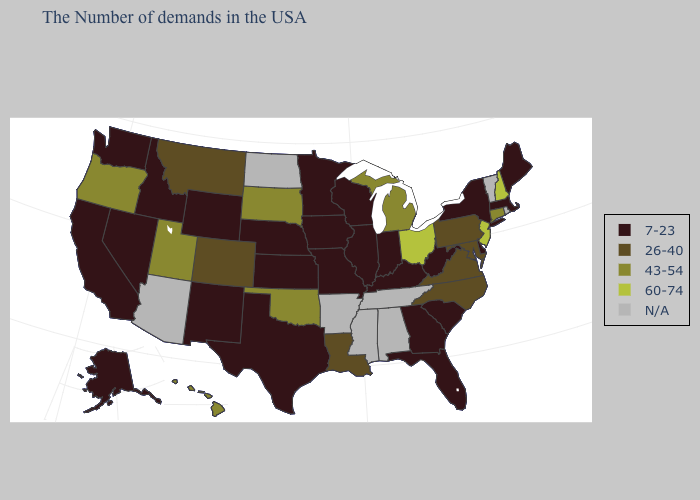Among the states that border Washington , which have the highest value?
Concise answer only. Oregon. How many symbols are there in the legend?
Be succinct. 5. Among the states that border Utah , which have the highest value?
Be succinct. Colorado. Does the map have missing data?
Short answer required. Yes. Name the states that have a value in the range N/A?
Quick response, please. Rhode Island, Vermont, Alabama, Tennessee, Mississippi, Arkansas, North Dakota, Arizona. Does Massachusetts have the highest value in the Northeast?
Concise answer only. No. What is the highest value in the USA?
Give a very brief answer. 60-74. What is the value of South Dakota?
Keep it brief. 43-54. Among the states that border New Hampshire , which have the highest value?
Short answer required. Maine, Massachusetts. What is the lowest value in states that border Pennsylvania?
Give a very brief answer. 7-23. What is the value of Illinois?
Be succinct. 7-23. What is the value of Kansas?
Give a very brief answer. 7-23. Is the legend a continuous bar?
Give a very brief answer. No. Does the map have missing data?
Be succinct. Yes. Is the legend a continuous bar?
Write a very short answer. No. 